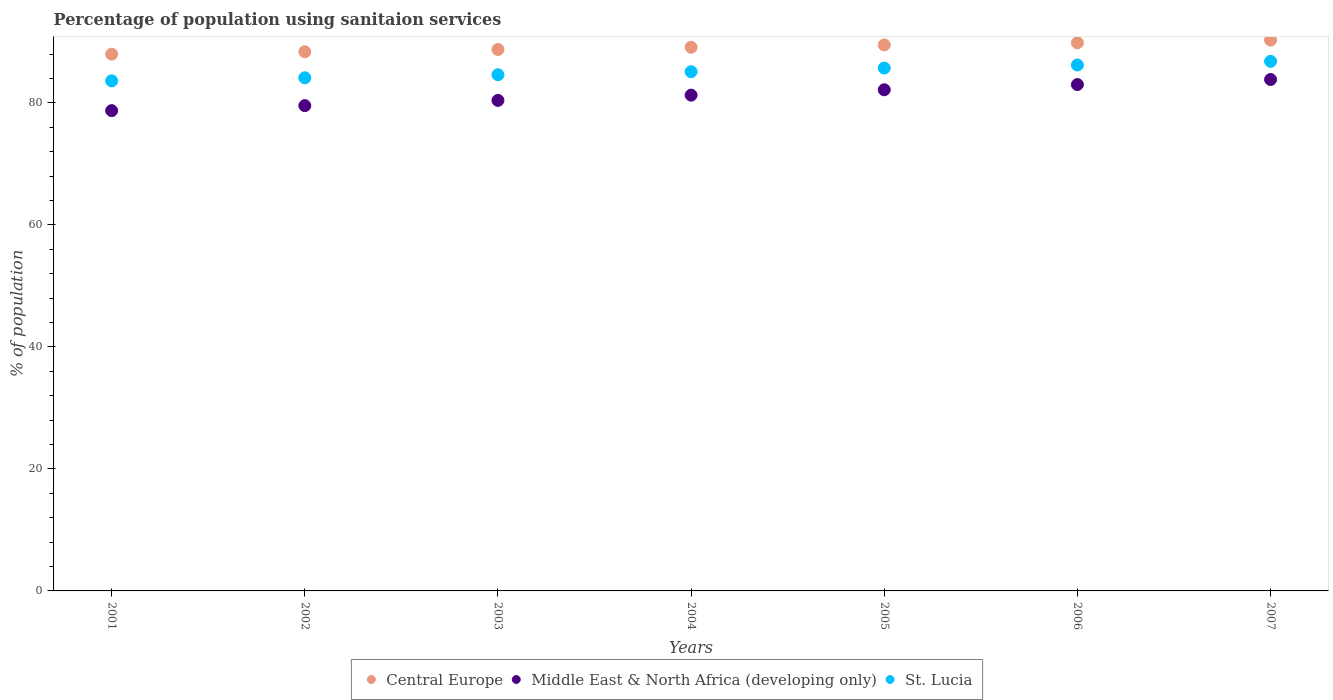What is the percentage of population using sanitaion services in Middle East & North Africa (developing only) in 2004?
Your response must be concise. 81.26. Across all years, what is the maximum percentage of population using sanitaion services in Middle East & North Africa (developing only)?
Provide a short and direct response. 83.82. Across all years, what is the minimum percentage of population using sanitaion services in St. Lucia?
Your answer should be very brief. 83.6. In which year was the percentage of population using sanitaion services in St. Lucia minimum?
Your response must be concise. 2001. What is the total percentage of population using sanitaion services in St. Lucia in the graph?
Provide a short and direct response. 596.1. What is the difference between the percentage of population using sanitaion services in Central Europe in 2002 and that in 2005?
Offer a very short reply. -1.12. What is the difference between the percentage of population using sanitaion services in Central Europe in 2004 and the percentage of population using sanitaion services in Middle East & North Africa (developing only) in 2001?
Provide a short and direct response. 10.39. What is the average percentage of population using sanitaion services in Central Europe per year?
Provide a short and direct response. 89.11. In the year 2004, what is the difference between the percentage of population using sanitaion services in St. Lucia and percentage of population using sanitaion services in Central Europe?
Keep it short and to the point. -4.01. What is the ratio of the percentage of population using sanitaion services in Middle East & North Africa (developing only) in 2002 to that in 2005?
Offer a very short reply. 0.97. Is the percentage of population using sanitaion services in Central Europe in 2003 less than that in 2004?
Your answer should be very brief. Yes. Is the difference between the percentage of population using sanitaion services in St. Lucia in 2001 and 2003 greater than the difference between the percentage of population using sanitaion services in Central Europe in 2001 and 2003?
Your response must be concise. No. What is the difference between the highest and the second highest percentage of population using sanitaion services in Central Europe?
Provide a short and direct response. 0.44. What is the difference between the highest and the lowest percentage of population using sanitaion services in St. Lucia?
Provide a short and direct response. 3.2. Is the percentage of population using sanitaion services in St. Lucia strictly greater than the percentage of population using sanitaion services in Central Europe over the years?
Offer a very short reply. No. How many years are there in the graph?
Your response must be concise. 7. What is the difference between two consecutive major ticks on the Y-axis?
Ensure brevity in your answer.  20. Are the values on the major ticks of Y-axis written in scientific E-notation?
Offer a terse response. No. Does the graph contain grids?
Give a very brief answer. No. Where does the legend appear in the graph?
Your response must be concise. Bottom center. How many legend labels are there?
Keep it short and to the point. 3. What is the title of the graph?
Offer a terse response. Percentage of population using sanitaion services. What is the label or title of the X-axis?
Your response must be concise. Years. What is the label or title of the Y-axis?
Offer a terse response. % of population. What is the % of population of Central Europe in 2001?
Your answer should be very brief. 87.98. What is the % of population in Middle East & North Africa (developing only) in 2001?
Your response must be concise. 78.72. What is the % of population of St. Lucia in 2001?
Ensure brevity in your answer.  83.6. What is the % of population of Central Europe in 2002?
Give a very brief answer. 88.37. What is the % of population of Middle East & North Africa (developing only) in 2002?
Your answer should be compact. 79.54. What is the % of population in St. Lucia in 2002?
Your answer should be compact. 84.1. What is the % of population of Central Europe in 2003?
Provide a succinct answer. 88.74. What is the % of population of Middle East & North Africa (developing only) in 2003?
Provide a short and direct response. 80.4. What is the % of population in St. Lucia in 2003?
Ensure brevity in your answer.  84.6. What is the % of population in Central Europe in 2004?
Offer a terse response. 89.11. What is the % of population in Middle East & North Africa (developing only) in 2004?
Offer a terse response. 81.26. What is the % of population in St. Lucia in 2004?
Offer a very short reply. 85.1. What is the % of population in Central Europe in 2005?
Ensure brevity in your answer.  89.49. What is the % of population of Middle East & North Africa (developing only) in 2005?
Make the answer very short. 82.14. What is the % of population in St. Lucia in 2005?
Offer a terse response. 85.7. What is the % of population of Central Europe in 2006?
Your response must be concise. 89.84. What is the % of population in Middle East & North Africa (developing only) in 2006?
Your answer should be compact. 82.99. What is the % of population in St. Lucia in 2006?
Offer a terse response. 86.2. What is the % of population of Central Europe in 2007?
Give a very brief answer. 90.28. What is the % of population of Middle East & North Africa (developing only) in 2007?
Your response must be concise. 83.82. What is the % of population of St. Lucia in 2007?
Give a very brief answer. 86.8. Across all years, what is the maximum % of population of Central Europe?
Make the answer very short. 90.28. Across all years, what is the maximum % of population of Middle East & North Africa (developing only)?
Offer a terse response. 83.82. Across all years, what is the maximum % of population of St. Lucia?
Ensure brevity in your answer.  86.8. Across all years, what is the minimum % of population of Central Europe?
Provide a succinct answer. 87.98. Across all years, what is the minimum % of population of Middle East & North Africa (developing only)?
Offer a very short reply. 78.72. Across all years, what is the minimum % of population of St. Lucia?
Provide a short and direct response. 83.6. What is the total % of population in Central Europe in the graph?
Your answer should be compact. 623.8. What is the total % of population of Middle East & North Africa (developing only) in the graph?
Ensure brevity in your answer.  568.86. What is the total % of population of St. Lucia in the graph?
Provide a short and direct response. 596.1. What is the difference between the % of population in Central Europe in 2001 and that in 2002?
Offer a very short reply. -0.39. What is the difference between the % of population in Middle East & North Africa (developing only) in 2001 and that in 2002?
Make the answer very short. -0.82. What is the difference between the % of population of Central Europe in 2001 and that in 2003?
Make the answer very short. -0.77. What is the difference between the % of population in Middle East & North Africa (developing only) in 2001 and that in 2003?
Your answer should be very brief. -1.68. What is the difference between the % of population in St. Lucia in 2001 and that in 2003?
Offer a terse response. -1. What is the difference between the % of population in Central Europe in 2001 and that in 2004?
Offer a terse response. -1.13. What is the difference between the % of population in Middle East & North Africa (developing only) in 2001 and that in 2004?
Your answer should be very brief. -2.54. What is the difference between the % of population of St. Lucia in 2001 and that in 2004?
Keep it short and to the point. -1.5. What is the difference between the % of population in Central Europe in 2001 and that in 2005?
Provide a short and direct response. -1.51. What is the difference between the % of population of Middle East & North Africa (developing only) in 2001 and that in 2005?
Provide a succinct answer. -3.42. What is the difference between the % of population in Central Europe in 2001 and that in 2006?
Give a very brief answer. -1.86. What is the difference between the % of population in Middle East & North Africa (developing only) in 2001 and that in 2006?
Your answer should be very brief. -4.27. What is the difference between the % of population in Central Europe in 2001 and that in 2007?
Make the answer very short. -2.3. What is the difference between the % of population in Middle East & North Africa (developing only) in 2001 and that in 2007?
Keep it short and to the point. -5.1. What is the difference between the % of population of Central Europe in 2002 and that in 2003?
Provide a short and direct response. -0.37. What is the difference between the % of population of Middle East & North Africa (developing only) in 2002 and that in 2003?
Keep it short and to the point. -0.86. What is the difference between the % of population of Central Europe in 2002 and that in 2004?
Your answer should be compact. -0.74. What is the difference between the % of population of Middle East & North Africa (developing only) in 2002 and that in 2004?
Ensure brevity in your answer.  -1.72. What is the difference between the % of population of Central Europe in 2002 and that in 2005?
Offer a terse response. -1.12. What is the difference between the % of population in Middle East & North Africa (developing only) in 2002 and that in 2005?
Provide a short and direct response. -2.6. What is the difference between the % of population in Central Europe in 2002 and that in 2006?
Your answer should be very brief. -1.47. What is the difference between the % of population of Middle East & North Africa (developing only) in 2002 and that in 2006?
Make the answer very short. -3.45. What is the difference between the % of population in St. Lucia in 2002 and that in 2006?
Keep it short and to the point. -2.1. What is the difference between the % of population in Central Europe in 2002 and that in 2007?
Make the answer very short. -1.91. What is the difference between the % of population of Middle East & North Africa (developing only) in 2002 and that in 2007?
Ensure brevity in your answer.  -4.28. What is the difference between the % of population of Central Europe in 2003 and that in 2004?
Make the answer very short. -0.36. What is the difference between the % of population in Middle East & North Africa (developing only) in 2003 and that in 2004?
Your response must be concise. -0.86. What is the difference between the % of population in Central Europe in 2003 and that in 2005?
Your answer should be compact. -0.75. What is the difference between the % of population in Middle East & North Africa (developing only) in 2003 and that in 2005?
Offer a terse response. -1.74. What is the difference between the % of population in Central Europe in 2003 and that in 2006?
Provide a succinct answer. -1.1. What is the difference between the % of population of Middle East & North Africa (developing only) in 2003 and that in 2006?
Your response must be concise. -2.6. What is the difference between the % of population of Central Europe in 2003 and that in 2007?
Provide a short and direct response. -1.54. What is the difference between the % of population in Middle East & North Africa (developing only) in 2003 and that in 2007?
Provide a succinct answer. -3.43. What is the difference between the % of population in Central Europe in 2004 and that in 2005?
Give a very brief answer. -0.38. What is the difference between the % of population in Middle East & North Africa (developing only) in 2004 and that in 2005?
Provide a short and direct response. -0.88. What is the difference between the % of population of Central Europe in 2004 and that in 2006?
Make the answer very short. -0.73. What is the difference between the % of population of Middle East & North Africa (developing only) in 2004 and that in 2006?
Offer a very short reply. -1.73. What is the difference between the % of population of Central Europe in 2004 and that in 2007?
Your response must be concise. -1.17. What is the difference between the % of population of Middle East & North Africa (developing only) in 2004 and that in 2007?
Your response must be concise. -2.56. What is the difference between the % of population of Central Europe in 2005 and that in 2006?
Make the answer very short. -0.35. What is the difference between the % of population in Middle East & North Africa (developing only) in 2005 and that in 2006?
Offer a very short reply. -0.85. What is the difference between the % of population in Central Europe in 2005 and that in 2007?
Keep it short and to the point. -0.79. What is the difference between the % of population of Middle East & North Africa (developing only) in 2005 and that in 2007?
Ensure brevity in your answer.  -1.68. What is the difference between the % of population of Central Europe in 2006 and that in 2007?
Provide a short and direct response. -0.44. What is the difference between the % of population in Middle East & North Africa (developing only) in 2006 and that in 2007?
Offer a terse response. -0.83. What is the difference between the % of population in Central Europe in 2001 and the % of population in Middle East & North Africa (developing only) in 2002?
Give a very brief answer. 8.44. What is the difference between the % of population in Central Europe in 2001 and the % of population in St. Lucia in 2002?
Your answer should be compact. 3.88. What is the difference between the % of population of Middle East & North Africa (developing only) in 2001 and the % of population of St. Lucia in 2002?
Your answer should be very brief. -5.38. What is the difference between the % of population in Central Europe in 2001 and the % of population in Middle East & North Africa (developing only) in 2003?
Provide a succinct answer. 7.58. What is the difference between the % of population of Central Europe in 2001 and the % of population of St. Lucia in 2003?
Ensure brevity in your answer.  3.38. What is the difference between the % of population of Middle East & North Africa (developing only) in 2001 and the % of population of St. Lucia in 2003?
Give a very brief answer. -5.88. What is the difference between the % of population in Central Europe in 2001 and the % of population in Middle East & North Africa (developing only) in 2004?
Your answer should be very brief. 6.72. What is the difference between the % of population in Central Europe in 2001 and the % of population in St. Lucia in 2004?
Your answer should be compact. 2.88. What is the difference between the % of population of Middle East & North Africa (developing only) in 2001 and the % of population of St. Lucia in 2004?
Offer a terse response. -6.38. What is the difference between the % of population in Central Europe in 2001 and the % of population in Middle East & North Africa (developing only) in 2005?
Your answer should be compact. 5.84. What is the difference between the % of population of Central Europe in 2001 and the % of population of St. Lucia in 2005?
Give a very brief answer. 2.28. What is the difference between the % of population of Middle East & North Africa (developing only) in 2001 and the % of population of St. Lucia in 2005?
Your answer should be very brief. -6.98. What is the difference between the % of population in Central Europe in 2001 and the % of population in Middle East & North Africa (developing only) in 2006?
Keep it short and to the point. 4.98. What is the difference between the % of population in Central Europe in 2001 and the % of population in St. Lucia in 2006?
Provide a short and direct response. 1.78. What is the difference between the % of population in Middle East & North Africa (developing only) in 2001 and the % of population in St. Lucia in 2006?
Offer a very short reply. -7.48. What is the difference between the % of population of Central Europe in 2001 and the % of population of Middle East & North Africa (developing only) in 2007?
Your answer should be compact. 4.16. What is the difference between the % of population of Central Europe in 2001 and the % of population of St. Lucia in 2007?
Provide a succinct answer. 1.18. What is the difference between the % of population of Middle East & North Africa (developing only) in 2001 and the % of population of St. Lucia in 2007?
Offer a terse response. -8.08. What is the difference between the % of population in Central Europe in 2002 and the % of population in Middle East & North Africa (developing only) in 2003?
Keep it short and to the point. 7.97. What is the difference between the % of population of Central Europe in 2002 and the % of population of St. Lucia in 2003?
Give a very brief answer. 3.77. What is the difference between the % of population of Middle East & North Africa (developing only) in 2002 and the % of population of St. Lucia in 2003?
Your answer should be very brief. -5.06. What is the difference between the % of population in Central Europe in 2002 and the % of population in Middle East & North Africa (developing only) in 2004?
Your response must be concise. 7.11. What is the difference between the % of population in Central Europe in 2002 and the % of population in St. Lucia in 2004?
Give a very brief answer. 3.27. What is the difference between the % of population in Middle East & North Africa (developing only) in 2002 and the % of population in St. Lucia in 2004?
Your answer should be very brief. -5.56. What is the difference between the % of population of Central Europe in 2002 and the % of population of Middle East & North Africa (developing only) in 2005?
Offer a terse response. 6.23. What is the difference between the % of population in Central Europe in 2002 and the % of population in St. Lucia in 2005?
Keep it short and to the point. 2.67. What is the difference between the % of population of Middle East & North Africa (developing only) in 2002 and the % of population of St. Lucia in 2005?
Your answer should be compact. -6.16. What is the difference between the % of population in Central Europe in 2002 and the % of population in Middle East & North Africa (developing only) in 2006?
Offer a terse response. 5.38. What is the difference between the % of population of Central Europe in 2002 and the % of population of St. Lucia in 2006?
Your response must be concise. 2.17. What is the difference between the % of population of Middle East & North Africa (developing only) in 2002 and the % of population of St. Lucia in 2006?
Offer a very short reply. -6.66. What is the difference between the % of population in Central Europe in 2002 and the % of population in Middle East & North Africa (developing only) in 2007?
Ensure brevity in your answer.  4.55. What is the difference between the % of population in Central Europe in 2002 and the % of population in St. Lucia in 2007?
Offer a very short reply. 1.57. What is the difference between the % of population of Middle East & North Africa (developing only) in 2002 and the % of population of St. Lucia in 2007?
Make the answer very short. -7.26. What is the difference between the % of population of Central Europe in 2003 and the % of population of Middle East & North Africa (developing only) in 2004?
Make the answer very short. 7.48. What is the difference between the % of population of Central Europe in 2003 and the % of population of St. Lucia in 2004?
Ensure brevity in your answer.  3.64. What is the difference between the % of population of Middle East & North Africa (developing only) in 2003 and the % of population of St. Lucia in 2004?
Your answer should be very brief. -4.7. What is the difference between the % of population of Central Europe in 2003 and the % of population of Middle East & North Africa (developing only) in 2005?
Offer a very short reply. 6.6. What is the difference between the % of population in Central Europe in 2003 and the % of population in St. Lucia in 2005?
Give a very brief answer. 3.04. What is the difference between the % of population of Middle East & North Africa (developing only) in 2003 and the % of population of St. Lucia in 2005?
Keep it short and to the point. -5.3. What is the difference between the % of population of Central Europe in 2003 and the % of population of Middle East & North Africa (developing only) in 2006?
Provide a succinct answer. 5.75. What is the difference between the % of population in Central Europe in 2003 and the % of population in St. Lucia in 2006?
Your response must be concise. 2.54. What is the difference between the % of population of Middle East & North Africa (developing only) in 2003 and the % of population of St. Lucia in 2006?
Provide a short and direct response. -5.8. What is the difference between the % of population in Central Europe in 2003 and the % of population in Middle East & North Africa (developing only) in 2007?
Keep it short and to the point. 4.92. What is the difference between the % of population in Central Europe in 2003 and the % of population in St. Lucia in 2007?
Provide a short and direct response. 1.94. What is the difference between the % of population in Middle East & North Africa (developing only) in 2003 and the % of population in St. Lucia in 2007?
Your response must be concise. -6.4. What is the difference between the % of population in Central Europe in 2004 and the % of population in Middle East & North Africa (developing only) in 2005?
Make the answer very short. 6.97. What is the difference between the % of population in Central Europe in 2004 and the % of population in St. Lucia in 2005?
Provide a succinct answer. 3.41. What is the difference between the % of population of Middle East & North Africa (developing only) in 2004 and the % of population of St. Lucia in 2005?
Provide a short and direct response. -4.44. What is the difference between the % of population of Central Europe in 2004 and the % of population of Middle East & North Africa (developing only) in 2006?
Keep it short and to the point. 6.11. What is the difference between the % of population in Central Europe in 2004 and the % of population in St. Lucia in 2006?
Your answer should be compact. 2.91. What is the difference between the % of population of Middle East & North Africa (developing only) in 2004 and the % of population of St. Lucia in 2006?
Make the answer very short. -4.94. What is the difference between the % of population of Central Europe in 2004 and the % of population of Middle East & North Africa (developing only) in 2007?
Provide a short and direct response. 5.29. What is the difference between the % of population of Central Europe in 2004 and the % of population of St. Lucia in 2007?
Your response must be concise. 2.31. What is the difference between the % of population in Middle East & North Africa (developing only) in 2004 and the % of population in St. Lucia in 2007?
Provide a succinct answer. -5.54. What is the difference between the % of population in Central Europe in 2005 and the % of population in Middle East & North Africa (developing only) in 2006?
Your answer should be compact. 6.5. What is the difference between the % of population in Central Europe in 2005 and the % of population in St. Lucia in 2006?
Give a very brief answer. 3.29. What is the difference between the % of population in Middle East & North Africa (developing only) in 2005 and the % of population in St. Lucia in 2006?
Offer a terse response. -4.06. What is the difference between the % of population of Central Europe in 2005 and the % of population of Middle East & North Africa (developing only) in 2007?
Give a very brief answer. 5.67. What is the difference between the % of population in Central Europe in 2005 and the % of population in St. Lucia in 2007?
Offer a very short reply. 2.69. What is the difference between the % of population of Middle East & North Africa (developing only) in 2005 and the % of population of St. Lucia in 2007?
Give a very brief answer. -4.66. What is the difference between the % of population of Central Europe in 2006 and the % of population of Middle East & North Africa (developing only) in 2007?
Your answer should be very brief. 6.02. What is the difference between the % of population of Central Europe in 2006 and the % of population of St. Lucia in 2007?
Your response must be concise. 3.04. What is the difference between the % of population of Middle East & North Africa (developing only) in 2006 and the % of population of St. Lucia in 2007?
Provide a short and direct response. -3.81. What is the average % of population in Central Europe per year?
Provide a short and direct response. 89.11. What is the average % of population in Middle East & North Africa (developing only) per year?
Give a very brief answer. 81.27. What is the average % of population of St. Lucia per year?
Your answer should be compact. 85.16. In the year 2001, what is the difference between the % of population of Central Europe and % of population of Middle East & North Africa (developing only)?
Provide a short and direct response. 9.26. In the year 2001, what is the difference between the % of population in Central Europe and % of population in St. Lucia?
Make the answer very short. 4.38. In the year 2001, what is the difference between the % of population in Middle East & North Africa (developing only) and % of population in St. Lucia?
Your answer should be very brief. -4.88. In the year 2002, what is the difference between the % of population in Central Europe and % of population in Middle East & North Africa (developing only)?
Offer a very short reply. 8.83. In the year 2002, what is the difference between the % of population of Central Europe and % of population of St. Lucia?
Ensure brevity in your answer.  4.27. In the year 2002, what is the difference between the % of population of Middle East & North Africa (developing only) and % of population of St. Lucia?
Offer a terse response. -4.56. In the year 2003, what is the difference between the % of population in Central Europe and % of population in Middle East & North Africa (developing only)?
Provide a succinct answer. 8.35. In the year 2003, what is the difference between the % of population in Central Europe and % of population in St. Lucia?
Make the answer very short. 4.14. In the year 2003, what is the difference between the % of population of Middle East & North Africa (developing only) and % of population of St. Lucia?
Ensure brevity in your answer.  -4.2. In the year 2004, what is the difference between the % of population of Central Europe and % of population of Middle East & North Africa (developing only)?
Make the answer very short. 7.85. In the year 2004, what is the difference between the % of population of Central Europe and % of population of St. Lucia?
Provide a short and direct response. 4.01. In the year 2004, what is the difference between the % of population of Middle East & North Africa (developing only) and % of population of St. Lucia?
Provide a short and direct response. -3.84. In the year 2005, what is the difference between the % of population of Central Europe and % of population of Middle East & North Africa (developing only)?
Offer a terse response. 7.35. In the year 2005, what is the difference between the % of population of Central Europe and % of population of St. Lucia?
Ensure brevity in your answer.  3.79. In the year 2005, what is the difference between the % of population in Middle East & North Africa (developing only) and % of population in St. Lucia?
Your answer should be compact. -3.56. In the year 2006, what is the difference between the % of population in Central Europe and % of population in Middle East & North Africa (developing only)?
Your response must be concise. 6.85. In the year 2006, what is the difference between the % of population of Central Europe and % of population of St. Lucia?
Offer a terse response. 3.64. In the year 2006, what is the difference between the % of population in Middle East & North Africa (developing only) and % of population in St. Lucia?
Provide a succinct answer. -3.21. In the year 2007, what is the difference between the % of population in Central Europe and % of population in Middle East & North Africa (developing only)?
Your response must be concise. 6.46. In the year 2007, what is the difference between the % of population of Central Europe and % of population of St. Lucia?
Provide a short and direct response. 3.48. In the year 2007, what is the difference between the % of population in Middle East & North Africa (developing only) and % of population in St. Lucia?
Offer a very short reply. -2.98. What is the ratio of the % of population of Central Europe in 2001 to that in 2002?
Your answer should be compact. 1. What is the ratio of the % of population of Middle East & North Africa (developing only) in 2001 to that in 2002?
Ensure brevity in your answer.  0.99. What is the ratio of the % of population of St. Lucia in 2001 to that in 2002?
Offer a very short reply. 0.99. What is the ratio of the % of population of Central Europe in 2001 to that in 2003?
Offer a very short reply. 0.99. What is the ratio of the % of population of Middle East & North Africa (developing only) in 2001 to that in 2003?
Your answer should be very brief. 0.98. What is the ratio of the % of population of St. Lucia in 2001 to that in 2003?
Offer a very short reply. 0.99. What is the ratio of the % of population in Central Europe in 2001 to that in 2004?
Ensure brevity in your answer.  0.99. What is the ratio of the % of population of Middle East & North Africa (developing only) in 2001 to that in 2004?
Offer a terse response. 0.97. What is the ratio of the % of population of St. Lucia in 2001 to that in 2004?
Make the answer very short. 0.98. What is the ratio of the % of population of Central Europe in 2001 to that in 2005?
Your response must be concise. 0.98. What is the ratio of the % of population in Middle East & North Africa (developing only) in 2001 to that in 2005?
Make the answer very short. 0.96. What is the ratio of the % of population of St. Lucia in 2001 to that in 2005?
Keep it short and to the point. 0.98. What is the ratio of the % of population in Central Europe in 2001 to that in 2006?
Provide a short and direct response. 0.98. What is the ratio of the % of population in Middle East & North Africa (developing only) in 2001 to that in 2006?
Ensure brevity in your answer.  0.95. What is the ratio of the % of population in St. Lucia in 2001 to that in 2006?
Ensure brevity in your answer.  0.97. What is the ratio of the % of population of Central Europe in 2001 to that in 2007?
Provide a short and direct response. 0.97. What is the ratio of the % of population of Middle East & North Africa (developing only) in 2001 to that in 2007?
Your response must be concise. 0.94. What is the ratio of the % of population in St. Lucia in 2001 to that in 2007?
Provide a short and direct response. 0.96. What is the ratio of the % of population in Central Europe in 2002 to that in 2003?
Your response must be concise. 1. What is the ratio of the % of population of Middle East & North Africa (developing only) in 2002 to that in 2003?
Your answer should be compact. 0.99. What is the ratio of the % of population of Middle East & North Africa (developing only) in 2002 to that in 2004?
Your answer should be very brief. 0.98. What is the ratio of the % of population in Central Europe in 2002 to that in 2005?
Your answer should be very brief. 0.99. What is the ratio of the % of population in Middle East & North Africa (developing only) in 2002 to that in 2005?
Make the answer very short. 0.97. What is the ratio of the % of population in St. Lucia in 2002 to that in 2005?
Keep it short and to the point. 0.98. What is the ratio of the % of population of Central Europe in 2002 to that in 2006?
Give a very brief answer. 0.98. What is the ratio of the % of population of Middle East & North Africa (developing only) in 2002 to that in 2006?
Give a very brief answer. 0.96. What is the ratio of the % of population of St. Lucia in 2002 to that in 2006?
Give a very brief answer. 0.98. What is the ratio of the % of population in Central Europe in 2002 to that in 2007?
Your answer should be very brief. 0.98. What is the ratio of the % of population of Middle East & North Africa (developing only) in 2002 to that in 2007?
Provide a succinct answer. 0.95. What is the ratio of the % of population in St. Lucia in 2002 to that in 2007?
Your answer should be compact. 0.97. What is the ratio of the % of population in Central Europe in 2003 to that in 2004?
Provide a short and direct response. 1. What is the ratio of the % of population in Middle East & North Africa (developing only) in 2003 to that in 2004?
Ensure brevity in your answer.  0.99. What is the ratio of the % of population of Central Europe in 2003 to that in 2005?
Your answer should be very brief. 0.99. What is the ratio of the % of population of Middle East & North Africa (developing only) in 2003 to that in 2005?
Provide a succinct answer. 0.98. What is the ratio of the % of population of St. Lucia in 2003 to that in 2005?
Offer a terse response. 0.99. What is the ratio of the % of population of Central Europe in 2003 to that in 2006?
Your answer should be compact. 0.99. What is the ratio of the % of population of Middle East & North Africa (developing only) in 2003 to that in 2006?
Keep it short and to the point. 0.97. What is the ratio of the % of population in St. Lucia in 2003 to that in 2006?
Make the answer very short. 0.98. What is the ratio of the % of population of Central Europe in 2003 to that in 2007?
Your answer should be compact. 0.98. What is the ratio of the % of population of Middle East & North Africa (developing only) in 2003 to that in 2007?
Ensure brevity in your answer.  0.96. What is the ratio of the % of population in St. Lucia in 2003 to that in 2007?
Keep it short and to the point. 0.97. What is the ratio of the % of population in Central Europe in 2004 to that in 2005?
Your answer should be very brief. 1. What is the ratio of the % of population of Middle East & North Africa (developing only) in 2004 to that in 2005?
Offer a terse response. 0.99. What is the ratio of the % of population of Central Europe in 2004 to that in 2006?
Provide a succinct answer. 0.99. What is the ratio of the % of population of Middle East & North Africa (developing only) in 2004 to that in 2006?
Provide a short and direct response. 0.98. What is the ratio of the % of population in St. Lucia in 2004 to that in 2006?
Your answer should be compact. 0.99. What is the ratio of the % of population of Middle East & North Africa (developing only) in 2004 to that in 2007?
Offer a very short reply. 0.97. What is the ratio of the % of population in St. Lucia in 2004 to that in 2007?
Ensure brevity in your answer.  0.98. What is the ratio of the % of population of Central Europe in 2005 to that in 2006?
Offer a very short reply. 1. What is the ratio of the % of population of Central Europe in 2005 to that in 2007?
Provide a succinct answer. 0.99. What is the ratio of the % of population of Middle East & North Africa (developing only) in 2005 to that in 2007?
Offer a terse response. 0.98. What is the ratio of the % of population in St. Lucia in 2005 to that in 2007?
Provide a short and direct response. 0.99. What is the ratio of the % of population in Middle East & North Africa (developing only) in 2006 to that in 2007?
Offer a very short reply. 0.99. What is the difference between the highest and the second highest % of population of Central Europe?
Make the answer very short. 0.44. What is the difference between the highest and the second highest % of population of Middle East & North Africa (developing only)?
Provide a short and direct response. 0.83. What is the difference between the highest and the second highest % of population of St. Lucia?
Provide a short and direct response. 0.6. What is the difference between the highest and the lowest % of population of Central Europe?
Provide a succinct answer. 2.3. What is the difference between the highest and the lowest % of population in Middle East & North Africa (developing only)?
Give a very brief answer. 5.1. What is the difference between the highest and the lowest % of population in St. Lucia?
Ensure brevity in your answer.  3.2. 